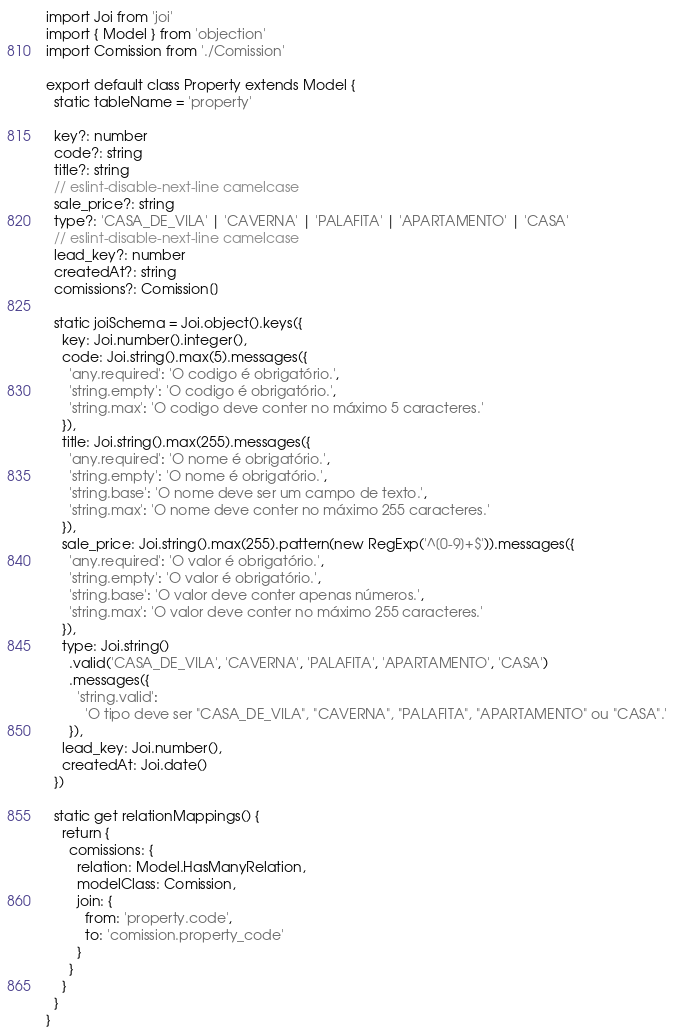<code> <loc_0><loc_0><loc_500><loc_500><_TypeScript_>import Joi from 'joi'
import { Model } from 'objection'
import Comission from './Comission'

export default class Property extends Model {
  static tableName = 'property'

  key?: number
  code?: string
  title?: string
  // eslint-disable-next-line camelcase
  sale_price?: string
  type?: 'CASA_DE_VILA' | 'CAVERNA' | 'PALAFITA' | 'APARTAMENTO' | 'CASA'
  // eslint-disable-next-line camelcase
  lead_key?: number
  createdAt?: string
  comissions?: Comission[]

  static joiSchema = Joi.object().keys({
    key: Joi.number().integer(),
    code: Joi.string().max(5).messages({
      'any.required': 'O codigo é obrigatório.',
      'string.empty': 'O codigo é obrigatório.',
      'string.max': 'O codigo deve conter no máximo 5 caracteres.'
    }),
    title: Joi.string().max(255).messages({
      'any.required': 'O nome é obrigatório.',
      'string.empty': 'O nome é obrigatório.',
      'string.base': 'O nome deve ser um campo de texto.',
      'string.max': 'O nome deve conter no máximo 255 caracteres.'
    }),
    sale_price: Joi.string().max(255).pattern(new RegExp('^[0-9]+$')).messages({
      'any.required': 'O valor é obrigatório.',
      'string.empty': 'O valor é obrigatório.',
      'string.base': 'O valor deve conter apenas números.',
      'string.max': 'O valor deve conter no máximo 255 caracteres.'
    }),
    type: Joi.string()
      .valid('CASA_DE_VILA', 'CAVERNA', 'PALAFITA', 'APARTAMENTO', 'CASA')
      .messages({
        'string.valid':
          'O tipo deve ser "CASA_DE_VILA", "CAVERNA", "PALAFITA", "APARTAMENTO" ou "CASA".'
      }),
    lead_key: Joi.number(),
    createdAt: Joi.date()
  })

  static get relationMappings() {
    return {
      comissions: {
        relation: Model.HasManyRelation,
        modelClass: Comission,
        join: {
          from: 'property.code',
          to: 'comission.property_code'
        }
      }
    }
  }
}
</code> 